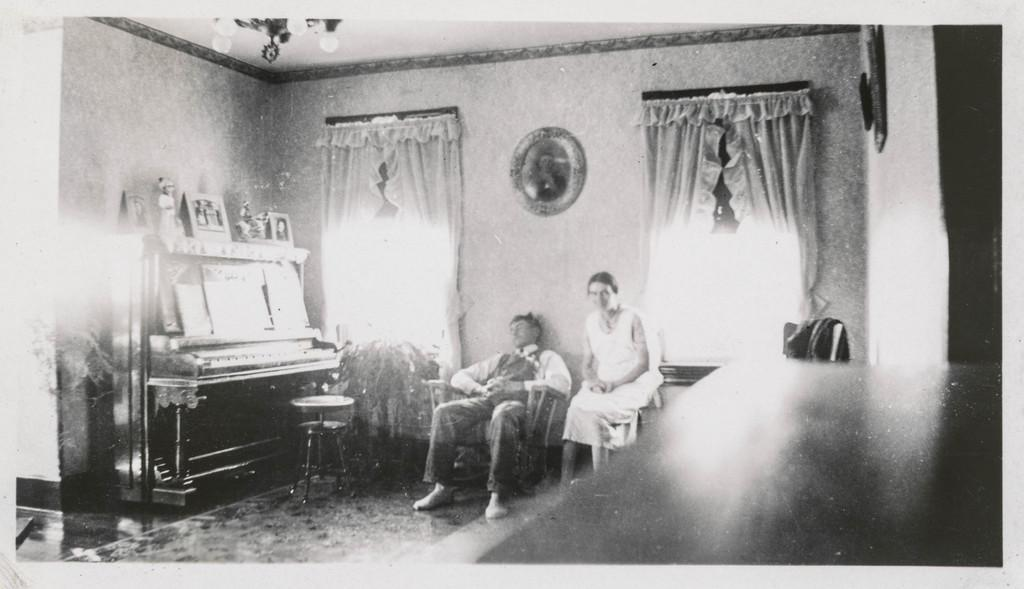What are the people in the image doing? There is a couple sitting in the image. What can be seen on the windows in the image? There are curtains in the image. What is hanging on the wall in the image? There are photo frames on the wall. What type of furniture is present in the image? There is a stool and chairs in the image. What is the price of the stool in the image? The price of the stool is not mentioned in the image, as it is not a fact about the image. 